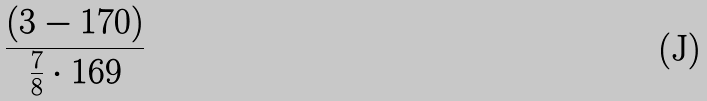Convert formula to latex. <formula><loc_0><loc_0><loc_500><loc_500>\frac { ( 3 - 1 7 0 ) } { \frac { 7 } { 8 } \cdot 1 6 9 }</formula> 